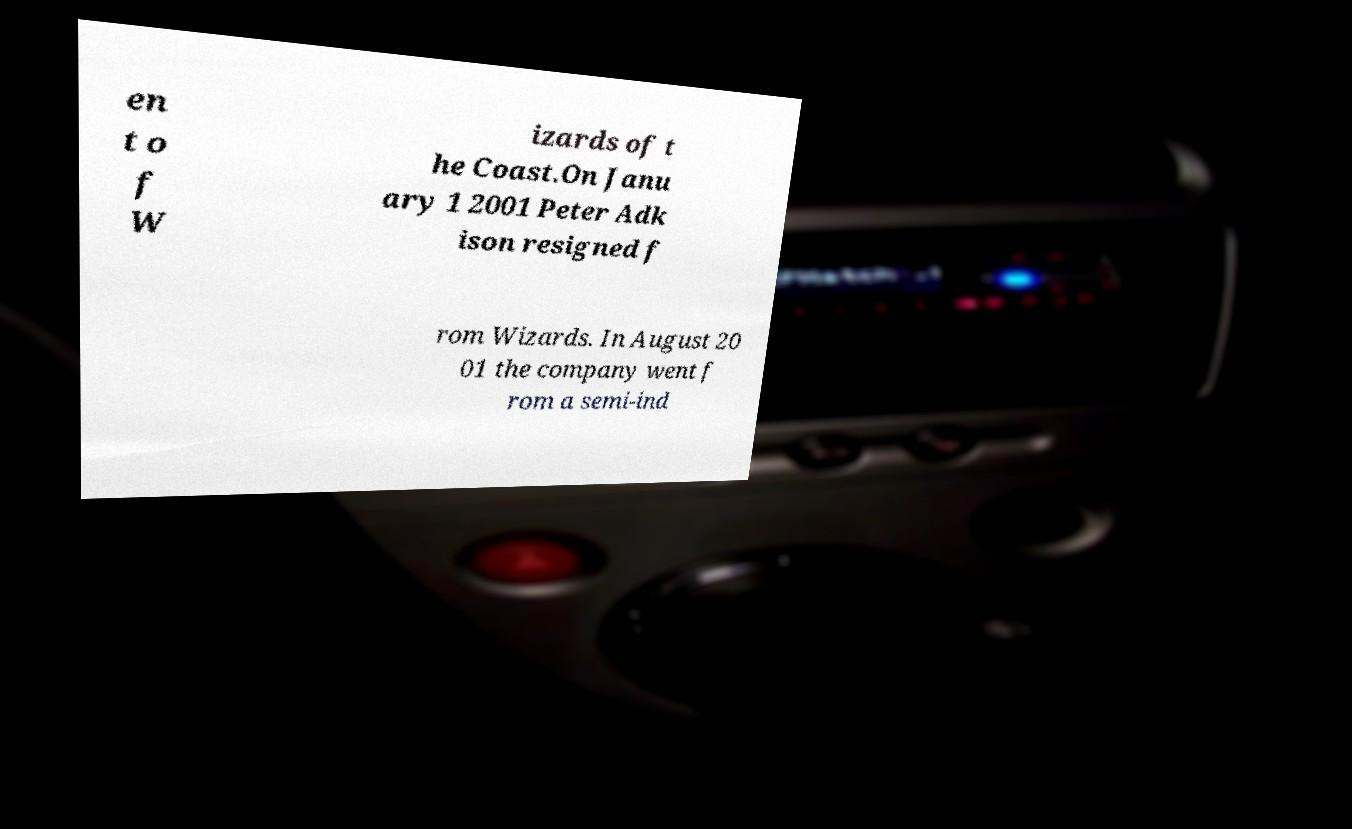Please read and relay the text visible in this image. What does it say? en t o f W izards of t he Coast.On Janu ary 1 2001 Peter Adk ison resigned f rom Wizards. In August 20 01 the company went f rom a semi-ind 